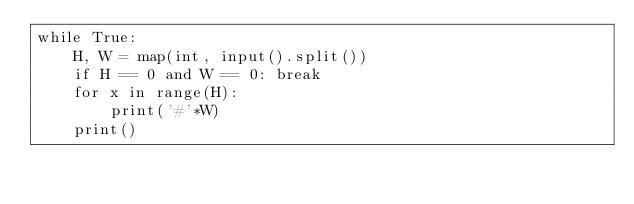<code> <loc_0><loc_0><loc_500><loc_500><_Python_>while True:
    H, W = map(int, input().split())
    if H == 0 and W == 0: break
    for x in range(H):
        print('#'*W)
    print()

</code> 